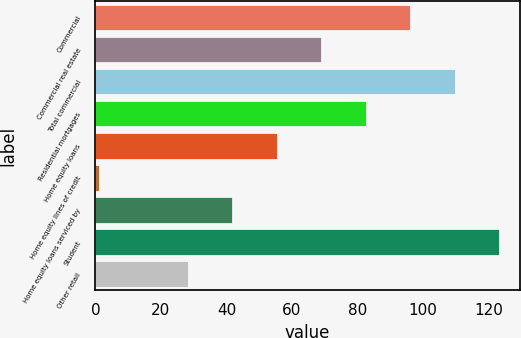Convert chart. <chart><loc_0><loc_0><loc_500><loc_500><bar_chart><fcel>Commercial<fcel>Commercial real estate<fcel>Total commercial<fcel>Residential mortgages<fcel>Home equity loans<fcel>Home equity lines of credit<fcel>Home equity loans serviced by<fcel>Student<fcel>Other retail<nl><fcel>96.2<fcel>69<fcel>109.8<fcel>82.6<fcel>55.4<fcel>1<fcel>41.8<fcel>123.4<fcel>28.2<nl></chart> 